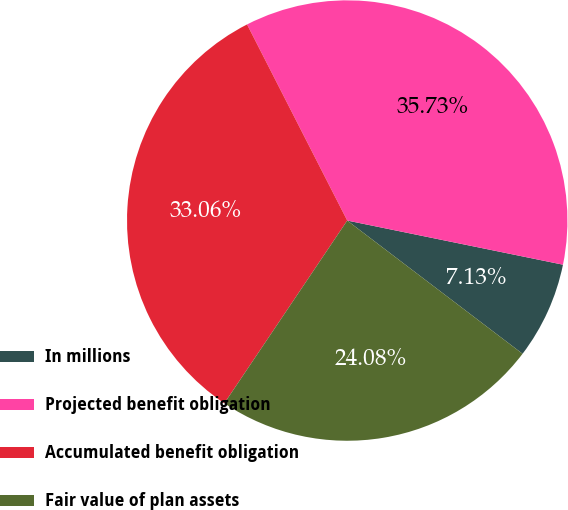Convert chart to OTSL. <chart><loc_0><loc_0><loc_500><loc_500><pie_chart><fcel>In millions<fcel>Projected benefit obligation<fcel>Accumulated benefit obligation<fcel>Fair value of plan assets<nl><fcel>7.13%<fcel>35.73%<fcel>33.06%<fcel>24.08%<nl></chart> 